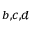Convert formula to latex. <formula><loc_0><loc_0><loc_500><loc_500>^ { b , c , d }</formula> 